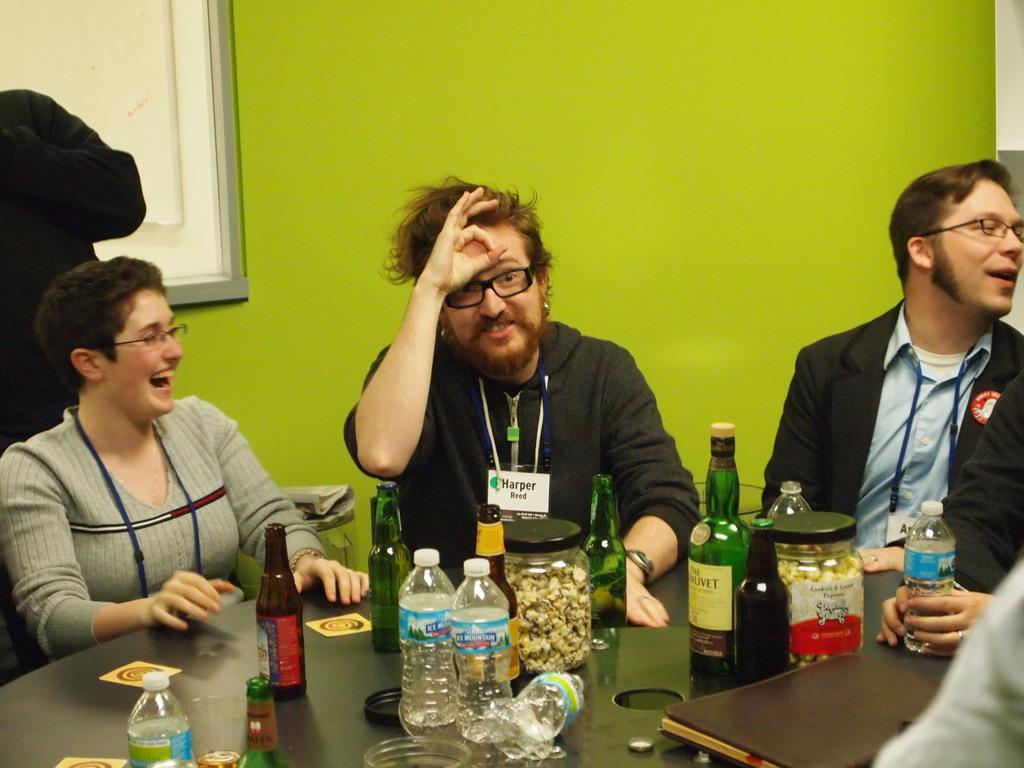How would you summarize this image in a sentence or two? In this picture we can see three persons sitting in front of table, there are glass bottles, water bottles, jars, caps present on the table, on the left side there is a person standing, in the background there is a wall, there is a book here. 